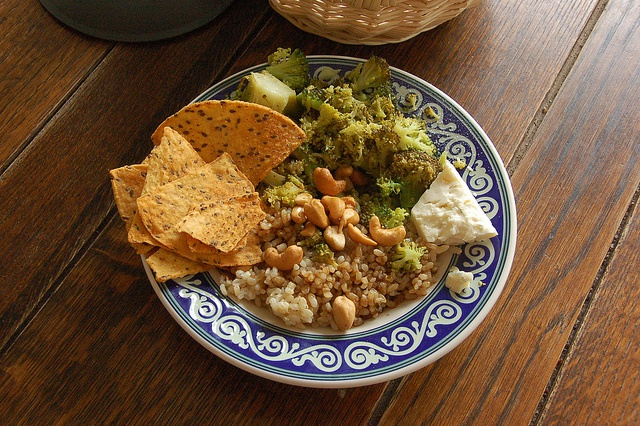Describe the objects in this image and their specific colors. I can see dining table in black, maroon, brown, and olive tones, broccoli in maroon, olive, and black tones, broccoli in maroon, olive, and tan tones, broccoli in maroon, olive, and tan tones, and broccoli in maroon, olive, and black tones in this image. 